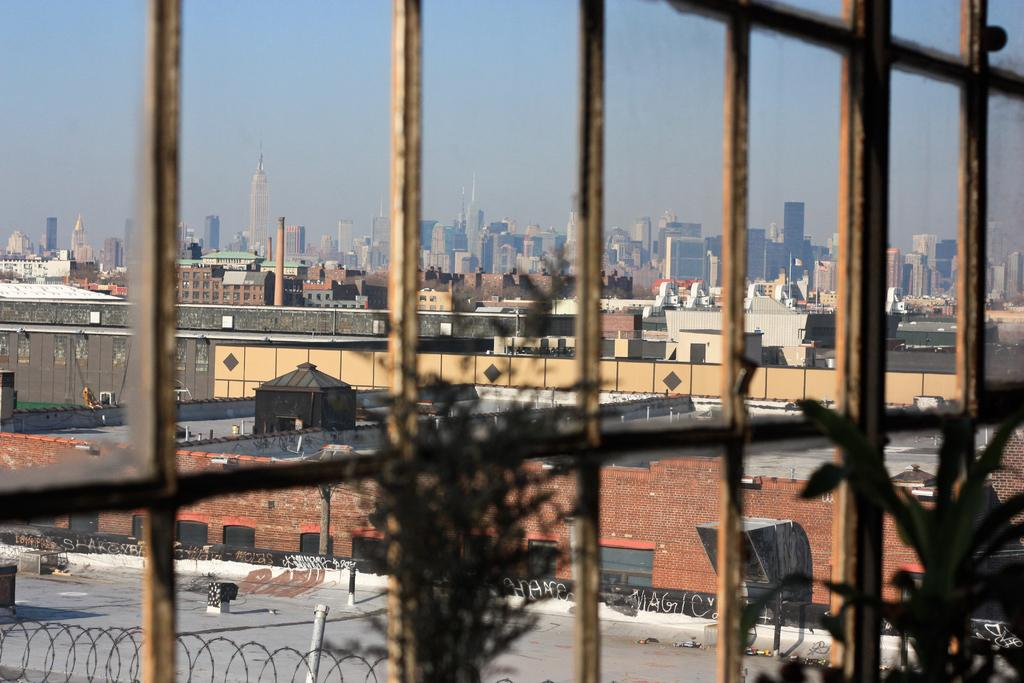What type of structures can be seen in the image? There are buildings in the image. What other elements are present in the image besides buildings? There are plants and some objects in the image. What can be seen in the background of the image? The sky is visible in the background of the image. What type of company is represented by the woman in the image? There is no woman present in the image, so it is not possible to determine what type of company she might represent. 